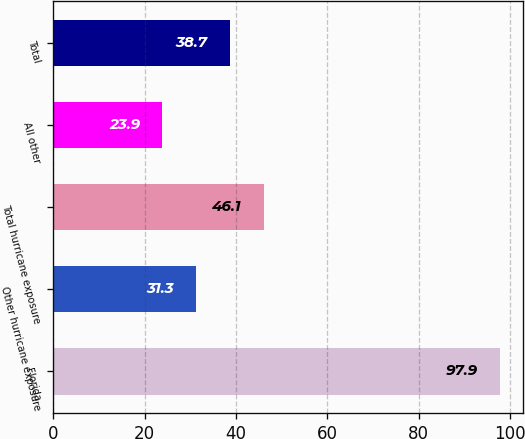<chart> <loc_0><loc_0><loc_500><loc_500><bar_chart><fcel>Florida<fcel>Other hurricane exposure<fcel>Total hurricane exposure<fcel>All other<fcel>Total<nl><fcel>97.9<fcel>31.3<fcel>46.1<fcel>23.9<fcel>38.7<nl></chart> 